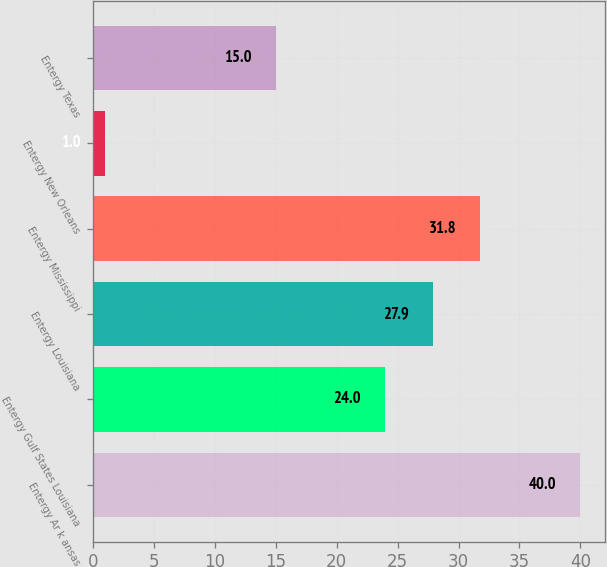Convert chart. <chart><loc_0><loc_0><loc_500><loc_500><bar_chart><fcel>Entergy Ar k ansas<fcel>Entergy Gulf States Louisiana<fcel>Entergy Louisiana<fcel>Entergy Mississippi<fcel>Entergy New Orleans<fcel>Entergy Texas<nl><fcel>40<fcel>24<fcel>27.9<fcel>31.8<fcel>1<fcel>15<nl></chart> 